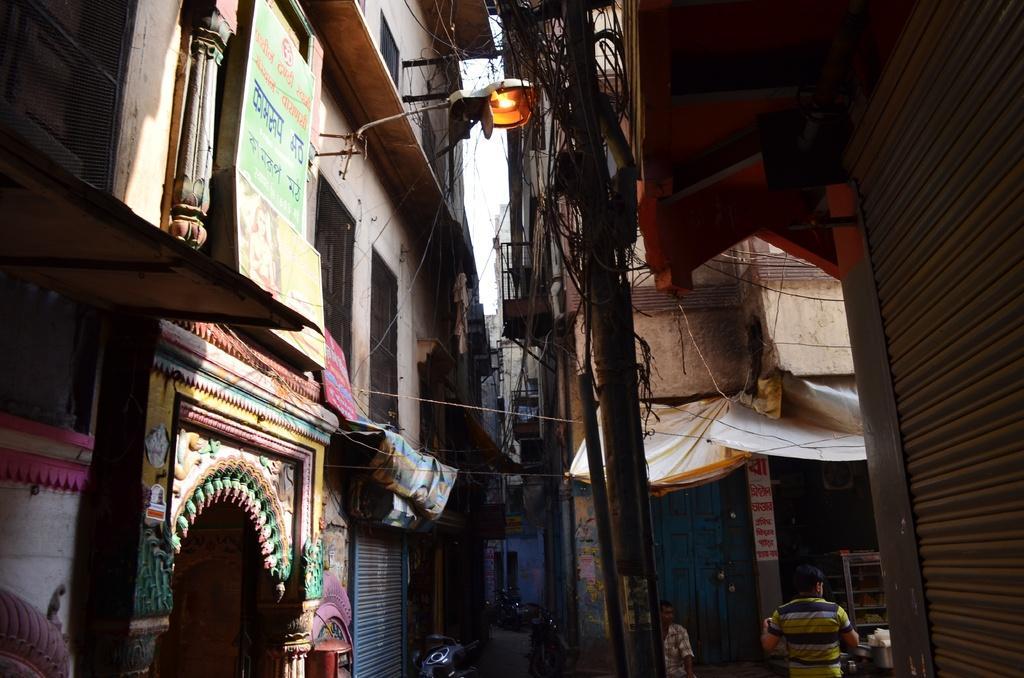How would you summarize this image in a sentence or two? In this image there are a few people walking on the streets and there are bikes and bicycles parked on the road, around them there are buildings, on the buildings there are banners, in front of the buildings there are closed shutters and there are lamps and electric poles with cables on it, there are name boards on the building and there are tents and covers in front of the buildings. 